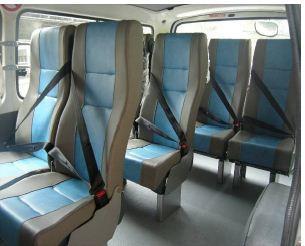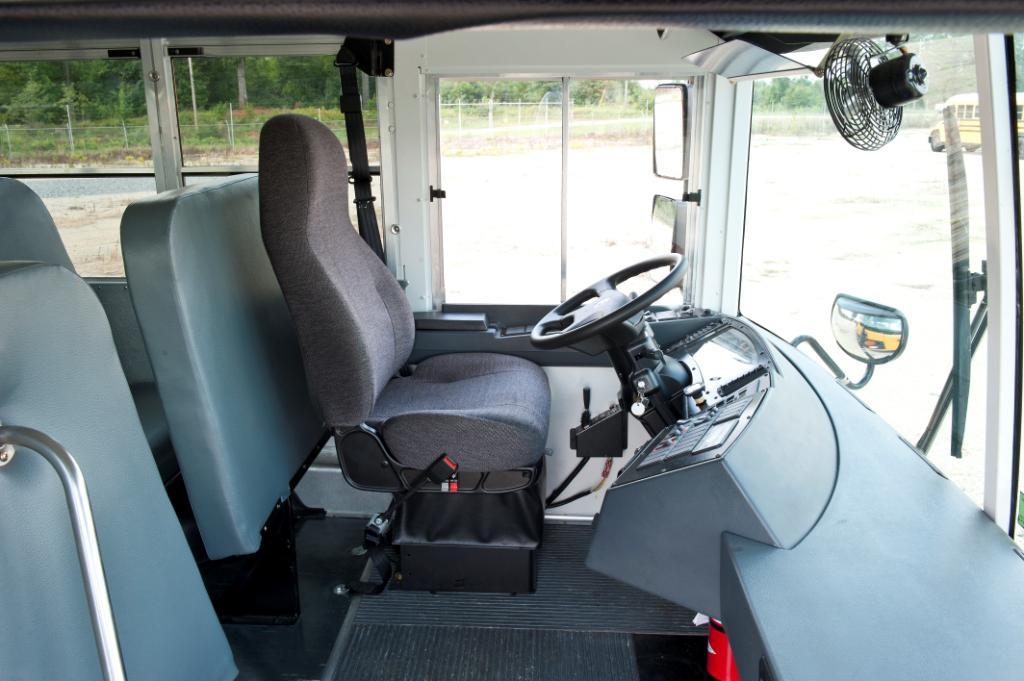The first image is the image on the left, the second image is the image on the right. Given the left and right images, does the statement "In one of the images the steering wheel is visible." hold true? Answer yes or no. Yes. The first image is the image on the left, the second image is the image on the right. Examine the images to the left and right. Is the description "One image shows a head-on view of the aisle inside a bus, which has grayish seats and black seatbelts with bright yellow locking mechanisms." accurate? Answer yes or no. No. 